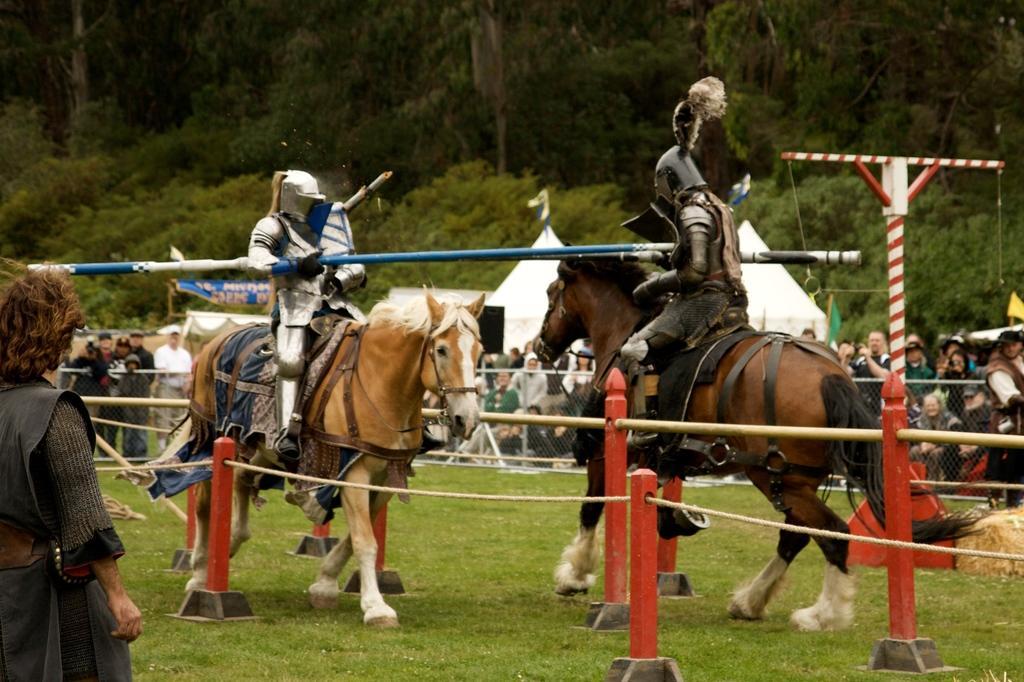How would you summarize this image in a sentence or two? In this image there are two horses running on the ground. There are people sitting on the horses. They are wearing costumes. Around the horse's there is a fencing. There is grass on the ground. There are few people standing and few sitting. In the background there are tents and trees. 